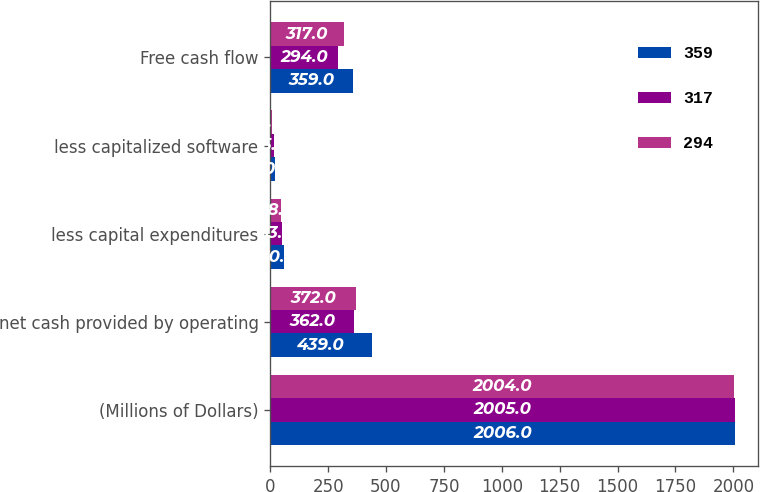Convert chart to OTSL. <chart><loc_0><loc_0><loc_500><loc_500><stacked_bar_chart><ecel><fcel>(Millions of Dollars)<fcel>net cash provided by operating<fcel>less capital expenditures<fcel>less capitalized software<fcel>Free cash flow<nl><fcel>359<fcel>2006<fcel>439<fcel>60<fcel>20<fcel>359<nl><fcel>317<fcel>2005<fcel>362<fcel>53<fcel>15<fcel>294<nl><fcel>294<fcel>2004<fcel>372<fcel>48<fcel>7<fcel>317<nl></chart> 